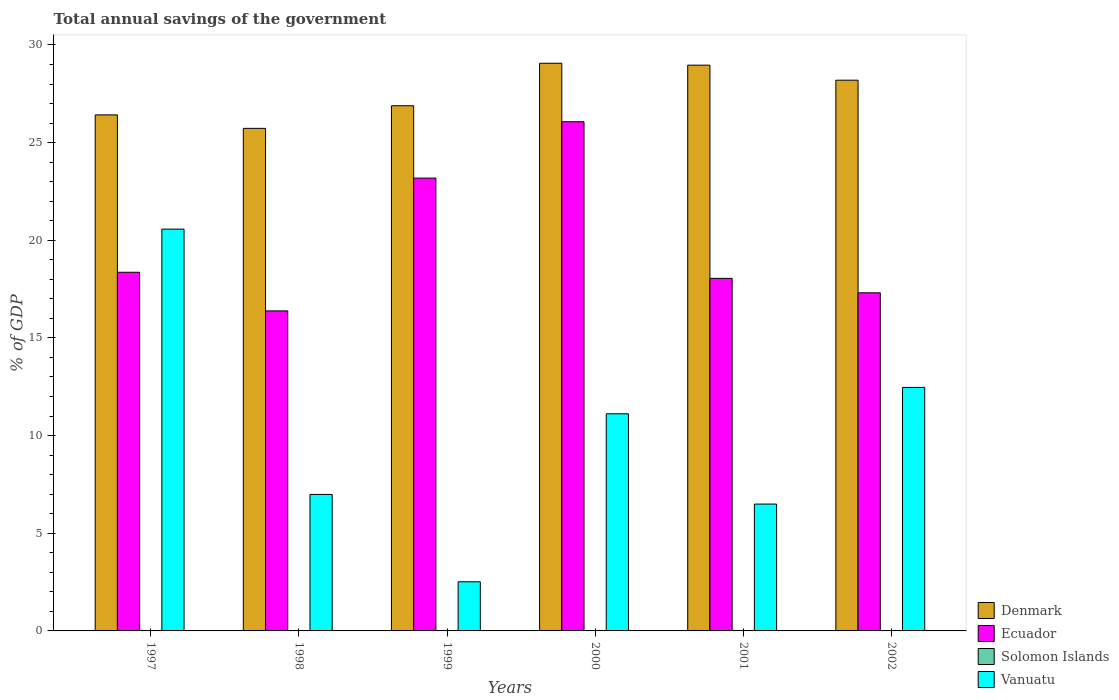How many bars are there on the 5th tick from the right?
Offer a terse response. 3. What is the label of the 1st group of bars from the left?
Give a very brief answer. 1997. Across all years, what is the maximum total annual savings of the government in Ecuador?
Ensure brevity in your answer.  26.07. Across all years, what is the minimum total annual savings of the government in Vanuatu?
Provide a short and direct response. 2.52. What is the total total annual savings of the government in Ecuador in the graph?
Your answer should be compact. 119.36. What is the difference between the total annual savings of the government in Vanuatu in 1997 and that in 2001?
Make the answer very short. 14.08. What is the difference between the total annual savings of the government in Ecuador in 2002 and the total annual savings of the government in Denmark in 1999?
Ensure brevity in your answer.  -9.58. In the year 1999, what is the difference between the total annual savings of the government in Vanuatu and total annual savings of the government in Ecuador?
Give a very brief answer. -20.67. What is the ratio of the total annual savings of the government in Vanuatu in 1998 to that in 2000?
Ensure brevity in your answer.  0.63. Is the total annual savings of the government in Vanuatu in 1997 less than that in 2001?
Ensure brevity in your answer.  No. Is the difference between the total annual savings of the government in Vanuatu in 1997 and 2002 greater than the difference between the total annual savings of the government in Ecuador in 1997 and 2002?
Ensure brevity in your answer.  Yes. What is the difference between the highest and the second highest total annual savings of the government in Vanuatu?
Your answer should be very brief. 8.1. What is the difference between the highest and the lowest total annual savings of the government in Ecuador?
Offer a very short reply. 9.68. Is the sum of the total annual savings of the government in Vanuatu in 2000 and 2002 greater than the maximum total annual savings of the government in Denmark across all years?
Ensure brevity in your answer.  No. Is it the case that in every year, the sum of the total annual savings of the government in Ecuador and total annual savings of the government in Denmark is greater than the sum of total annual savings of the government in Vanuatu and total annual savings of the government in Solomon Islands?
Ensure brevity in your answer.  Yes. Is it the case that in every year, the sum of the total annual savings of the government in Ecuador and total annual savings of the government in Vanuatu is greater than the total annual savings of the government in Denmark?
Offer a terse response. No. How many bars are there?
Make the answer very short. 18. How many years are there in the graph?
Give a very brief answer. 6. Are the values on the major ticks of Y-axis written in scientific E-notation?
Your answer should be compact. No. Does the graph contain grids?
Offer a terse response. No. How many legend labels are there?
Your response must be concise. 4. What is the title of the graph?
Provide a short and direct response. Total annual savings of the government. What is the label or title of the X-axis?
Your answer should be compact. Years. What is the label or title of the Y-axis?
Keep it short and to the point. % of GDP. What is the % of GDP in Denmark in 1997?
Make the answer very short. 26.42. What is the % of GDP of Ecuador in 1997?
Your answer should be compact. 18.36. What is the % of GDP in Solomon Islands in 1997?
Your answer should be compact. 0. What is the % of GDP of Vanuatu in 1997?
Keep it short and to the point. 20.57. What is the % of GDP of Denmark in 1998?
Offer a terse response. 25.73. What is the % of GDP of Ecuador in 1998?
Your answer should be very brief. 16.38. What is the % of GDP of Vanuatu in 1998?
Provide a succinct answer. 6.99. What is the % of GDP of Denmark in 1999?
Your answer should be compact. 26.89. What is the % of GDP in Ecuador in 1999?
Your answer should be very brief. 23.18. What is the % of GDP of Solomon Islands in 1999?
Make the answer very short. 0. What is the % of GDP in Vanuatu in 1999?
Make the answer very short. 2.52. What is the % of GDP in Denmark in 2000?
Give a very brief answer. 29.06. What is the % of GDP in Ecuador in 2000?
Give a very brief answer. 26.07. What is the % of GDP in Vanuatu in 2000?
Ensure brevity in your answer.  11.12. What is the % of GDP in Denmark in 2001?
Offer a very short reply. 28.97. What is the % of GDP in Ecuador in 2001?
Provide a succinct answer. 18.05. What is the % of GDP in Solomon Islands in 2001?
Offer a terse response. 0. What is the % of GDP of Vanuatu in 2001?
Give a very brief answer. 6.49. What is the % of GDP in Denmark in 2002?
Provide a succinct answer. 28.2. What is the % of GDP in Ecuador in 2002?
Offer a very short reply. 17.31. What is the % of GDP of Vanuatu in 2002?
Your answer should be compact. 12.47. Across all years, what is the maximum % of GDP in Denmark?
Make the answer very short. 29.06. Across all years, what is the maximum % of GDP of Ecuador?
Your answer should be very brief. 26.07. Across all years, what is the maximum % of GDP in Vanuatu?
Provide a succinct answer. 20.57. Across all years, what is the minimum % of GDP of Denmark?
Provide a short and direct response. 25.73. Across all years, what is the minimum % of GDP of Ecuador?
Your answer should be very brief. 16.38. Across all years, what is the minimum % of GDP of Vanuatu?
Offer a terse response. 2.52. What is the total % of GDP of Denmark in the graph?
Offer a terse response. 165.26. What is the total % of GDP in Ecuador in the graph?
Your answer should be compact. 119.36. What is the total % of GDP of Solomon Islands in the graph?
Offer a very short reply. 0. What is the total % of GDP in Vanuatu in the graph?
Your answer should be compact. 60.15. What is the difference between the % of GDP of Denmark in 1997 and that in 1998?
Your response must be concise. 0.69. What is the difference between the % of GDP of Ecuador in 1997 and that in 1998?
Provide a short and direct response. 1.98. What is the difference between the % of GDP in Vanuatu in 1997 and that in 1998?
Offer a very short reply. 13.58. What is the difference between the % of GDP of Denmark in 1997 and that in 1999?
Provide a succinct answer. -0.47. What is the difference between the % of GDP in Ecuador in 1997 and that in 1999?
Ensure brevity in your answer.  -4.82. What is the difference between the % of GDP of Vanuatu in 1997 and that in 1999?
Offer a terse response. 18.05. What is the difference between the % of GDP in Denmark in 1997 and that in 2000?
Ensure brevity in your answer.  -2.64. What is the difference between the % of GDP in Ecuador in 1997 and that in 2000?
Give a very brief answer. -7.71. What is the difference between the % of GDP in Vanuatu in 1997 and that in 2000?
Your answer should be compact. 9.45. What is the difference between the % of GDP of Denmark in 1997 and that in 2001?
Ensure brevity in your answer.  -2.55. What is the difference between the % of GDP of Ecuador in 1997 and that in 2001?
Give a very brief answer. 0.31. What is the difference between the % of GDP of Vanuatu in 1997 and that in 2001?
Provide a succinct answer. 14.08. What is the difference between the % of GDP of Denmark in 1997 and that in 2002?
Keep it short and to the point. -1.78. What is the difference between the % of GDP of Ecuador in 1997 and that in 2002?
Your response must be concise. 1.05. What is the difference between the % of GDP of Vanuatu in 1997 and that in 2002?
Offer a terse response. 8.1. What is the difference between the % of GDP in Denmark in 1998 and that in 1999?
Make the answer very short. -1.16. What is the difference between the % of GDP in Ecuador in 1998 and that in 1999?
Offer a terse response. -6.8. What is the difference between the % of GDP of Vanuatu in 1998 and that in 1999?
Offer a terse response. 4.47. What is the difference between the % of GDP of Denmark in 1998 and that in 2000?
Provide a short and direct response. -3.33. What is the difference between the % of GDP in Ecuador in 1998 and that in 2000?
Ensure brevity in your answer.  -9.68. What is the difference between the % of GDP of Vanuatu in 1998 and that in 2000?
Your answer should be compact. -4.13. What is the difference between the % of GDP in Denmark in 1998 and that in 2001?
Offer a terse response. -3.24. What is the difference between the % of GDP of Ecuador in 1998 and that in 2001?
Provide a short and direct response. -1.67. What is the difference between the % of GDP in Vanuatu in 1998 and that in 2001?
Provide a succinct answer. 0.49. What is the difference between the % of GDP of Denmark in 1998 and that in 2002?
Ensure brevity in your answer.  -2.47. What is the difference between the % of GDP in Ecuador in 1998 and that in 2002?
Your response must be concise. -0.93. What is the difference between the % of GDP of Vanuatu in 1998 and that in 2002?
Offer a terse response. -5.48. What is the difference between the % of GDP of Denmark in 1999 and that in 2000?
Give a very brief answer. -2.17. What is the difference between the % of GDP in Ecuador in 1999 and that in 2000?
Ensure brevity in your answer.  -2.89. What is the difference between the % of GDP in Vanuatu in 1999 and that in 2000?
Your answer should be compact. -8.6. What is the difference between the % of GDP in Denmark in 1999 and that in 2001?
Your answer should be compact. -2.08. What is the difference between the % of GDP in Ecuador in 1999 and that in 2001?
Give a very brief answer. 5.13. What is the difference between the % of GDP in Vanuatu in 1999 and that in 2001?
Make the answer very short. -3.98. What is the difference between the % of GDP in Denmark in 1999 and that in 2002?
Give a very brief answer. -1.31. What is the difference between the % of GDP of Ecuador in 1999 and that in 2002?
Provide a succinct answer. 5.87. What is the difference between the % of GDP of Vanuatu in 1999 and that in 2002?
Your response must be concise. -9.95. What is the difference between the % of GDP of Denmark in 2000 and that in 2001?
Provide a succinct answer. 0.1. What is the difference between the % of GDP of Ecuador in 2000 and that in 2001?
Your response must be concise. 8.02. What is the difference between the % of GDP of Vanuatu in 2000 and that in 2001?
Make the answer very short. 4.62. What is the difference between the % of GDP in Denmark in 2000 and that in 2002?
Give a very brief answer. 0.87. What is the difference between the % of GDP in Ecuador in 2000 and that in 2002?
Your response must be concise. 8.76. What is the difference between the % of GDP in Vanuatu in 2000 and that in 2002?
Make the answer very short. -1.35. What is the difference between the % of GDP of Denmark in 2001 and that in 2002?
Provide a short and direct response. 0.77. What is the difference between the % of GDP in Ecuador in 2001 and that in 2002?
Offer a terse response. 0.74. What is the difference between the % of GDP in Vanuatu in 2001 and that in 2002?
Your answer should be very brief. -5.97. What is the difference between the % of GDP in Denmark in 1997 and the % of GDP in Ecuador in 1998?
Your answer should be compact. 10.03. What is the difference between the % of GDP in Denmark in 1997 and the % of GDP in Vanuatu in 1998?
Provide a short and direct response. 19.43. What is the difference between the % of GDP of Ecuador in 1997 and the % of GDP of Vanuatu in 1998?
Make the answer very short. 11.37. What is the difference between the % of GDP in Denmark in 1997 and the % of GDP in Ecuador in 1999?
Give a very brief answer. 3.24. What is the difference between the % of GDP of Denmark in 1997 and the % of GDP of Vanuatu in 1999?
Ensure brevity in your answer.  23.9. What is the difference between the % of GDP in Ecuador in 1997 and the % of GDP in Vanuatu in 1999?
Make the answer very short. 15.85. What is the difference between the % of GDP in Denmark in 1997 and the % of GDP in Ecuador in 2000?
Your answer should be compact. 0.35. What is the difference between the % of GDP of Denmark in 1997 and the % of GDP of Vanuatu in 2000?
Your answer should be compact. 15.3. What is the difference between the % of GDP in Ecuador in 1997 and the % of GDP in Vanuatu in 2000?
Offer a terse response. 7.25. What is the difference between the % of GDP in Denmark in 1997 and the % of GDP in Ecuador in 2001?
Make the answer very short. 8.37. What is the difference between the % of GDP of Denmark in 1997 and the % of GDP of Vanuatu in 2001?
Offer a terse response. 19.93. What is the difference between the % of GDP in Ecuador in 1997 and the % of GDP in Vanuatu in 2001?
Provide a succinct answer. 11.87. What is the difference between the % of GDP of Denmark in 1997 and the % of GDP of Ecuador in 2002?
Keep it short and to the point. 9.11. What is the difference between the % of GDP in Denmark in 1997 and the % of GDP in Vanuatu in 2002?
Provide a short and direct response. 13.95. What is the difference between the % of GDP in Ecuador in 1997 and the % of GDP in Vanuatu in 2002?
Your response must be concise. 5.9. What is the difference between the % of GDP of Denmark in 1998 and the % of GDP of Ecuador in 1999?
Your response must be concise. 2.55. What is the difference between the % of GDP of Denmark in 1998 and the % of GDP of Vanuatu in 1999?
Provide a short and direct response. 23.21. What is the difference between the % of GDP of Ecuador in 1998 and the % of GDP of Vanuatu in 1999?
Ensure brevity in your answer.  13.87. What is the difference between the % of GDP in Denmark in 1998 and the % of GDP in Ecuador in 2000?
Provide a succinct answer. -0.34. What is the difference between the % of GDP of Denmark in 1998 and the % of GDP of Vanuatu in 2000?
Offer a very short reply. 14.61. What is the difference between the % of GDP in Ecuador in 1998 and the % of GDP in Vanuatu in 2000?
Your answer should be compact. 5.27. What is the difference between the % of GDP in Denmark in 1998 and the % of GDP in Ecuador in 2001?
Keep it short and to the point. 7.68. What is the difference between the % of GDP of Denmark in 1998 and the % of GDP of Vanuatu in 2001?
Give a very brief answer. 19.23. What is the difference between the % of GDP in Ecuador in 1998 and the % of GDP in Vanuatu in 2001?
Make the answer very short. 9.89. What is the difference between the % of GDP of Denmark in 1998 and the % of GDP of Ecuador in 2002?
Provide a succinct answer. 8.42. What is the difference between the % of GDP of Denmark in 1998 and the % of GDP of Vanuatu in 2002?
Your answer should be compact. 13.26. What is the difference between the % of GDP in Ecuador in 1998 and the % of GDP in Vanuatu in 2002?
Provide a succinct answer. 3.92. What is the difference between the % of GDP in Denmark in 1999 and the % of GDP in Ecuador in 2000?
Ensure brevity in your answer.  0.82. What is the difference between the % of GDP of Denmark in 1999 and the % of GDP of Vanuatu in 2000?
Make the answer very short. 15.77. What is the difference between the % of GDP in Ecuador in 1999 and the % of GDP in Vanuatu in 2000?
Your answer should be very brief. 12.07. What is the difference between the % of GDP of Denmark in 1999 and the % of GDP of Ecuador in 2001?
Your answer should be compact. 8.84. What is the difference between the % of GDP of Denmark in 1999 and the % of GDP of Vanuatu in 2001?
Keep it short and to the point. 20.39. What is the difference between the % of GDP in Ecuador in 1999 and the % of GDP in Vanuatu in 2001?
Provide a short and direct response. 16.69. What is the difference between the % of GDP in Denmark in 1999 and the % of GDP in Ecuador in 2002?
Ensure brevity in your answer.  9.58. What is the difference between the % of GDP of Denmark in 1999 and the % of GDP of Vanuatu in 2002?
Your response must be concise. 14.42. What is the difference between the % of GDP of Ecuador in 1999 and the % of GDP of Vanuatu in 2002?
Offer a very short reply. 10.72. What is the difference between the % of GDP in Denmark in 2000 and the % of GDP in Ecuador in 2001?
Your response must be concise. 11.01. What is the difference between the % of GDP of Denmark in 2000 and the % of GDP of Vanuatu in 2001?
Make the answer very short. 22.57. What is the difference between the % of GDP in Ecuador in 2000 and the % of GDP in Vanuatu in 2001?
Provide a succinct answer. 19.57. What is the difference between the % of GDP of Denmark in 2000 and the % of GDP of Ecuador in 2002?
Your response must be concise. 11.75. What is the difference between the % of GDP in Denmark in 2000 and the % of GDP in Vanuatu in 2002?
Your answer should be very brief. 16.6. What is the difference between the % of GDP of Ecuador in 2000 and the % of GDP of Vanuatu in 2002?
Your response must be concise. 13.6. What is the difference between the % of GDP in Denmark in 2001 and the % of GDP in Ecuador in 2002?
Keep it short and to the point. 11.65. What is the difference between the % of GDP of Denmark in 2001 and the % of GDP of Vanuatu in 2002?
Your answer should be very brief. 16.5. What is the difference between the % of GDP of Ecuador in 2001 and the % of GDP of Vanuatu in 2002?
Keep it short and to the point. 5.58. What is the average % of GDP of Denmark per year?
Your response must be concise. 27.54. What is the average % of GDP in Ecuador per year?
Provide a short and direct response. 19.89. What is the average % of GDP in Vanuatu per year?
Ensure brevity in your answer.  10.02. In the year 1997, what is the difference between the % of GDP in Denmark and % of GDP in Ecuador?
Provide a short and direct response. 8.06. In the year 1997, what is the difference between the % of GDP in Denmark and % of GDP in Vanuatu?
Provide a succinct answer. 5.85. In the year 1997, what is the difference between the % of GDP of Ecuador and % of GDP of Vanuatu?
Offer a terse response. -2.21. In the year 1998, what is the difference between the % of GDP in Denmark and % of GDP in Ecuador?
Your answer should be compact. 9.34. In the year 1998, what is the difference between the % of GDP of Denmark and % of GDP of Vanuatu?
Offer a terse response. 18.74. In the year 1998, what is the difference between the % of GDP in Ecuador and % of GDP in Vanuatu?
Your answer should be compact. 9.4. In the year 1999, what is the difference between the % of GDP of Denmark and % of GDP of Ecuador?
Provide a succinct answer. 3.71. In the year 1999, what is the difference between the % of GDP in Denmark and % of GDP in Vanuatu?
Offer a very short reply. 24.37. In the year 1999, what is the difference between the % of GDP in Ecuador and % of GDP in Vanuatu?
Your response must be concise. 20.67. In the year 2000, what is the difference between the % of GDP of Denmark and % of GDP of Ecuador?
Keep it short and to the point. 2.99. In the year 2000, what is the difference between the % of GDP in Denmark and % of GDP in Vanuatu?
Your response must be concise. 17.95. In the year 2000, what is the difference between the % of GDP in Ecuador and % of GDP in Vanuatu?
Provide a short and direct response. 14.95. In the year 2001, what is the difference between the % of GDP of Denmark and % of GDP of Ecuador?
Your response must be concise. 10.92. In the year 2001, what is the difference between the % of GDP of Denmark and % of GDP of Vanuatu?
Give a very brief answer. 22.47. In the year 2001, what is the difference between the % of GDP of Ecuador and % of GDP of Vanuatu?
Ensure brevity in your answer.  11.56. In the year 2002, what is the difference between the % of GDP of Denmark and % of GDP of Ecuador?
Keep it short and to the point. 10.88. In the year 2002, what is the difference between the % of GDP in Denmark and % of GDP in Vanuatu?
Your response must be concise. 15.73. In the year 2002, what is the difference between the % of GDP in Ecuador and % of GDP in Vanuatu?
Give a very brief answer. 4.84. What is the ratio of the % of GDP in Denmark in 1997 to that in 1998?
Ensure brevity in your answer.  1.03. What is the ratio of the % of GDP in Ecuador in 1997 to that in 1998?
Your answer should be very brief. 1.12. What is the ratio of the % of GDP in Vanuatu in 1997 to that in 1998?
Ensure brevity in your answer.  2.94. What is the ratio of the % of GDP of Denmark in 1997 to that in 1999?
Provide a succinct answer. 0.98. What is the ratio of the % of GDP of Ecuador in 1997 to that in 1999?
Give a very brief answer. 0.79. What is the ratio of the % of GDP in Vanuatu in 1997 to that in 1999?
Your answer should be compact. 8.18. What is the ratio of the % of GDP in Denmark in 1997 to that in 2000?
Make the answer very short. 0.91. What is the ratio of the % of GDP of Ecuador in 1997 to that in 2000?
Provide a succinct answer. 0.7. What is the ratio of the % of GDP in Vanuatu in 1997 to that in 2000?
Offer a terse response. 1.85. What is the ratio of the % of GDP of Denmark in 1997 to that in 2001?
Your answer should be very brief. 0.91. What is the ratio of the % of GDP of Ecuador in 1997 to that in 2001?
Offer a very short reply. 1.02. What is the ratio of the % of GDP in Vanuatu in 1997 to that in 2001?
Give a very brief answer. 3.17. What is the ratio of the % of GDP of Denmark in 1997 to that in 2002?
Offer a very short reply. 0.94. What is the ratio of the % of GDP in Ecuador in 1997 to that in 2002?
Provide a succinct answer. 1.06. What is the ratio of the % of GDP of Vanuatu in 1997 to that in 2002?
Keep it short and to the point. 1.65. What is the ratio of the % of GDP in Denmark in 1998 to that in 1999?
Provide a short and direct response. 0.96. What is the ratio of the % of GDP of Ecuador in 1998 to that in 1999?
Make the answer very short. 0.71. What is the ratio of the % of GDP in Vanuatu in 1998 to that in 1999?
Your response must be concise. 2.78. What is the ratio of the % of GDP in Denmark in 1998 to that in 2000?
Provide a succinct answer. 0.89. What is the ratio of the % of GDP in Ecuador in 1998 to that in 2000?
Make the answer very short. 0.63. What is the ratio of the % of GDP of Vanuatu in 1998 to that in 2000?
Give a very brief answer. 0.63. What is the ratio of the % of GDP in Denmark in 1998 to that in 2001?
Your response must be concise. 0.89. What is the ratio of the % of GDP in Ecuador in 1998 to that in 2001?
Provide a short and direct response. 0.91. What is the ratio of the % of GDP of Vanuatu in 1998 to that in 2001?
Make the answer very short. 1.08. What is the ratio of the % of GDP of Denmark in 1998 to that in 2002?
Offer a terse response. 0.91. What is the ratio of the % of GDP in Ecuador in 1998 to that in 2002?
Provide a short and direct response. 0.95. What is the ratio of the % of GDP in Vanuatu in 1998 to that in 2002?
Your response must be concise. 0.56. What is the ratio of the % of GDP in Denmark in 1999 to that in 2000?
Your response must be concise. 0.93. What is the ratio of the % of GDP in Ecuador in 1999 to that in 2000?
Provide a succinct answer. 0.89. What is the ratio of the % of GDP in Vanuatu in 1999 to that in 2000?
Offer a very short reply. 0.23. What is the ratio of the % of GDP of Denmark in 1999 to that in 2001?
Provide a succinct answer. 0.93. What is the ratio of the % of GDP in Ecuador in 1999 to that in 2001?
Keep it short and to the point. 1.28. What is the ratio of the % of GDP in Vanuatu in 1999 to that in 2001?
Your answer should be very brief. 0.39. What is the ratio of the % of GDP of Denmark in 1999 to that in 2002?
Your answer should be compact. 0.95. What is the ratio of the % of GDP in Ecuador in 1999 to that in 2002?
Provide a succinct answer. 1.34. What is the ratio of the % of GDP in Vanuatu in 1999 to that in 2002?
Your answer should be compact. 0.2. What is the ratio of the % of GDP in Ecuador in 2000 to that in 2001?
Provide a succinct answer. 1.44. What is the ratio of the % of GDP in Vanuatu in 2000 to that in 2001?
Provide a succinct answer. 1.71. What is the ratio of the % of GDP in Denmark in 2000 to that in 2002?
Offer a very short reply. 1.03. What is the ratio of the % of GDP in Ecuador in 2000 to that in 2002?
Offer a very short reply. 1.51. What is the ratio of the % of GDP in Vanuatu in 2000 to that in 2002?
Keep it short and to the point. 0.89. What is the ratio of the % of GDP in Denmark in 2001 to that in 2002?
Provide a succinct answer. 1.03. What is the ratio of the % of GDP in Ecuador in 2001 to that in 2002?
Your response must be concise. 1.04. What is the ratio of the % of GDP in Vanuatu in 2001 to that in 2002?
Keep it short and to the point. 0.52. What is the difference between the highest and the second highest % of GDP of Denmark?
Keep it short and to the point. 0.1. What is the difference between the highest and the second highest % of GDP of Ecuador?
Keep it short and to the point. 2.89. What is the difference between the highest and the second highest % of GDP in Vanuatu?
Provide a short and direct response. 8.1. What is the difference between the highest and the lowest % of GDP of Denmark?
Offer a very short reply. 3.33. What is the difference between the highest and the lowest % of GDP in Ecuador?
Provide a succinct answer. 9.68. What is the difference between the highest and the lowest % of GDP of Vanuatu?
Keep it short and to the point. 18.05. 